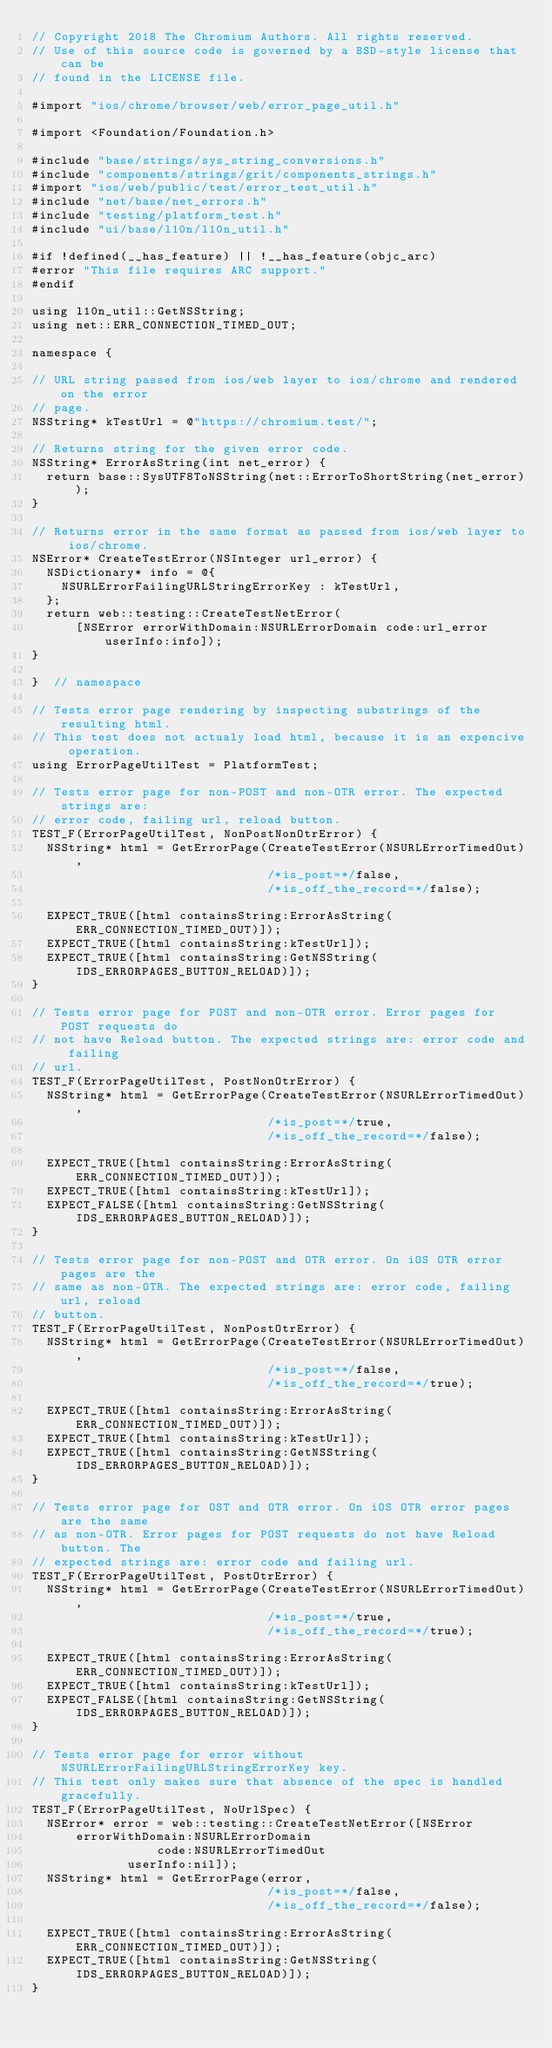<code> <loc_0><loc_0><loc_500><loc_500><_ObjectiveC_>// Copyright 2018 The Chromium Authors. All rights reserved.
// Use of this source code is governed by a BSD-style license that can be
// found in the LICENSE file.

#import "ios/chrome/browser/web/error_page_util.h"

#import <Foundation/Foundation.h>

#include "base/strings/sys_string_conversions.h"
#include "components/strings/grit/components_strings.h"
#import "ios/web/public/test/error_test_util.h"
#include "net/base/net_errors.h"
#include "testing/platform_test.h"
#include "ui/base/l10n/l10n_util.h"

#if !defined(__has_feature) || !__has_feature(objc_arc)
#error "This file requires ARC support."
#endif

using l10n_util::GetNSString;
using net::ERR_CONNECTION_TIMED_OUT;

namespace {

// URL string passed from ios/web layer to ios/chrome and rendered on the error
// page.
NSString* kTestUrl = @"https://chromium.test/";

// Returns string for the given error code.
NSString* ErrorAsString(int net_error) {
  return base::SysUTF8ToNSString(net::ErrorToShortString(net_error));
}

// Returns error in the same format as passed from ios/web layer to ios/chrome.
NSError* CreateTestError(NSInteger url_error) {
  NSDictionary* info = @{
    NSURLErrorFailingURLStringErrorKey : kTestUrl,
  };
  return web::testing::CreateTestNetError(
      [NSError errorWithDomain:NSURLErrorDomain code:url_error userInfo:info]);
}

}  // namespace

// Tests error page rendering by inspecting substrings of the resulting html.
// This test does not actualy load html, because it is an expencive operation.
using ErrorPageUtilTest = PlatformTest;

// Tests error page for non-POST and non-OTR error. The expected strings are:
// error code, failing url, reload button.
TEST_F(ErrorPageUtilTest, NonPostNonOtrError) {
  NSString* html = GetErrorPage(CreateTestError(NSURLErrorTimedOut),
                                /*is_post=*/false,
                                /*is_off_the_record=*/false);

  EXPECT_TRUE([html containsString:ErrorAsString(ERR_CONNECTION_TIMED_OUT)]);
  EXPECT_TRUE([html containsString:kTestUrl]);
  EXPECT_TRUE([html containsString:GetNSString(IDS_ERRORPAGES_BUTTON_RELOAD)]);
}

// Tests error page for POST and non-OTR error. Error pages for POST requests do
// not have Reload button. The expected strings are: error code and failing
// url.
TEST_F(ErrorPageUtilTest, PostNonOtrError) {
  NSString* html = GetErrorPage(CreateTestError(NSURLErrorTimedOut),
                                /*is_post=*/true,
                                /*is_off_the_record=*/false);

  EXPECT_TRUE([html containsString:ErrorAsString(ERR_CONNECTION_TIMED_OUT)]);
  EXPECT_TRUE([html containsString:kTestUrl]);
  EXPECT_FALSE([html containsString:GetNSString(IDS_ERRORPAGES_BUTTON_RELOAD)]);
}

// Tests error page for non-POST and OTR error. On iOS OTR error pages are the
// same as non-OTR. The expected strings are: error code, failing url, reload
// button.
TEST_F(ErrorPageUtilTest, NonPostOtrError) {
  NSString* html = GetErrorPage(CreateTestError(NSURLErrorTimedOut),
                                /*is_post=*/false,
                                /*is_off_the_record=*/true);

  EXPECT_TRUE([html containsString:ErrorAsString(ERR_CONNECTION_TIMED_OUT)]);
  EXPECT_TRUE([html containsString:kTestUrl]);
  EXPECT_TRUE([html containsString:GetNSString(IDS_ERRORPAGES_BUTTON_RELOAD)]);
}

// Tests error page for OST and OTR error. On iOS OTR error pages are the same
// as non-OTR. Error pages for POST requests do not have Reload button. The
// expected strings are: error code and failing url.
TEST_F(ErrorPageUtilTest, PostOtrError) {
  NSString* html = GetErrorPage(CreateTestError(NSURLErrorTimedOut),
                                /*is_post=*/true,
                                /*is_off_the_record=*/true);

  EXPECT_TRUE([html containsString:ErrorAsString(ERR_CONNECTION_TIMED_OUT)]);
  EXPECT_TRUE([html containsString:kTestUrl]);
  EXPECT_FALSE([html containsString:GetNSString(IDS_ERRORPAGES_BUTTON_RELOAD)]);
}

// Tests error page for error without NSURLErrorFailingURLStringErrorKey key.
// This test only makes sure that absence of the spec is handled gracefully.
TEST_F(ErrorPageUtilTest, NoUrlSpec) {
  NSError* error = web::testing::CreateTestNetError([NSError
      errorWithDomain:NSURLErrorDomain
                 code:NSURLErrorTimedOut
             userInfo:nil]);
  NSString* html = GetErrorPage(error,
                                /*is_post=*/false,
                                /*is_off_the_record=*/false);

  EXPECT_TRUE([html containsString:ErrorAsString(ERR_CONNECTION_TIMED_OUT)]);
  EXPECT_TRUE([html containsString:GetNSString(IDS_ERRORPAGES_BUTTON_RELOAD)]);
}
</code> 